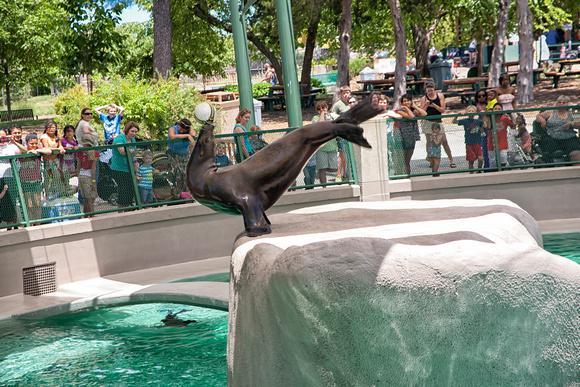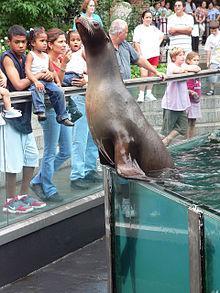The first image is the image on the left, the second image is the image on the right. For the images shown, is this caption "Each image shows a seal performing in a show, and one image shows a seal balancing on a stone ledge with at least part of its body held in the air." true? Answer yes or no. Yes. The first image is the image on the left, the second image is the image on the right. For the images shown, is this caption "there are seals in a pool encased in glass fencing" true? Answer yes or no. Yes. 